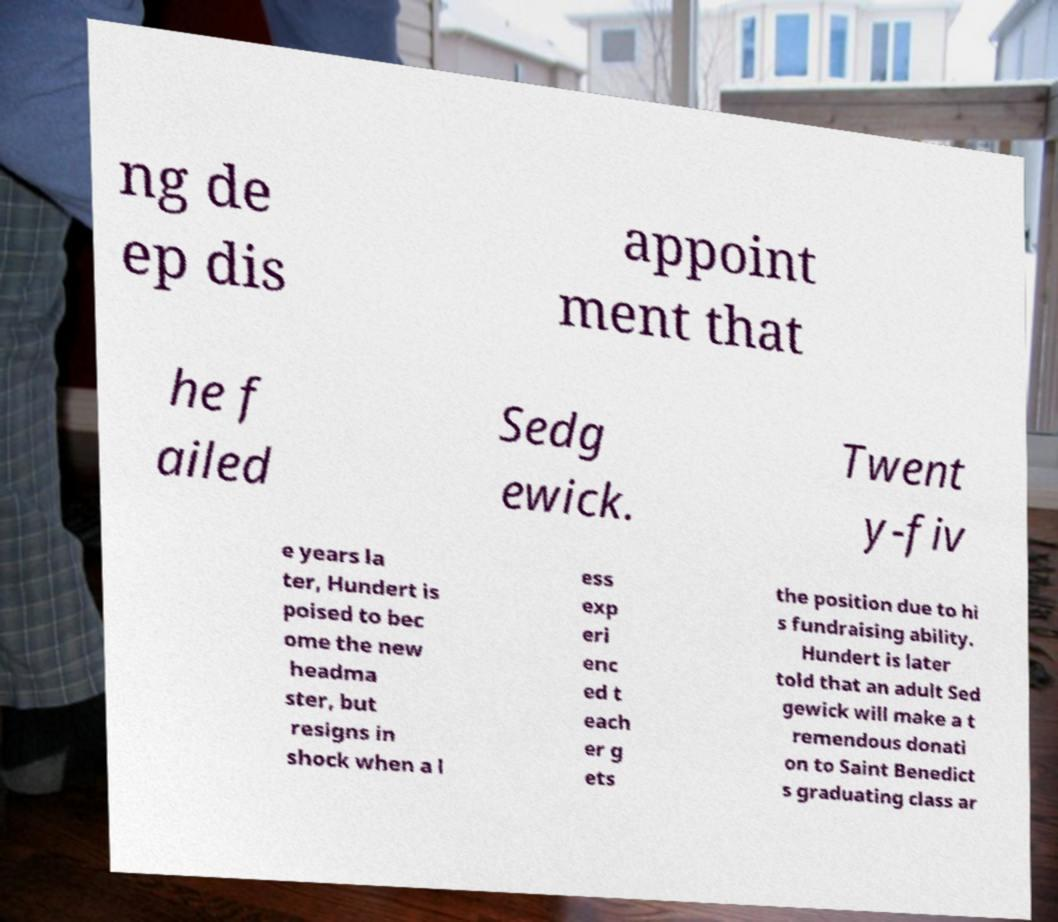There's text embedded in this image that I need extracted. Can you transcribe it verbatim? ng de ep dis appoint ment that he f ailed Sedg ewick. Twent y-fiv e years la ter, Hundert is poised to bec ome the new headma ster, but resigns in shock when a l ess exp eri enc ed t each er g ets the position due to hi s fundraising ability. Hundert is later told that an adult Sed gewick will make a t remendous donati on to Saint Benedict s graduating class ar 